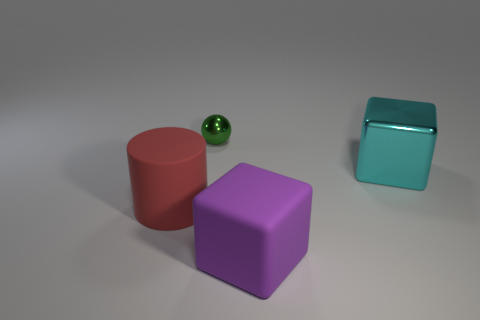Add 3 big gray matte balls. How many objects exist? 7 Subtract all spheres. How many objects are left? 3 Add 1 purple matte things. How many purple matte things are left? 2 Add 1 large cyan balls. How many large cyan balls exist? 1 Subtract 0 green cubes. How many objects are left? 4 Subtract all large blocks. Subtract all purple rubber blocks. How many objects are left? 1 